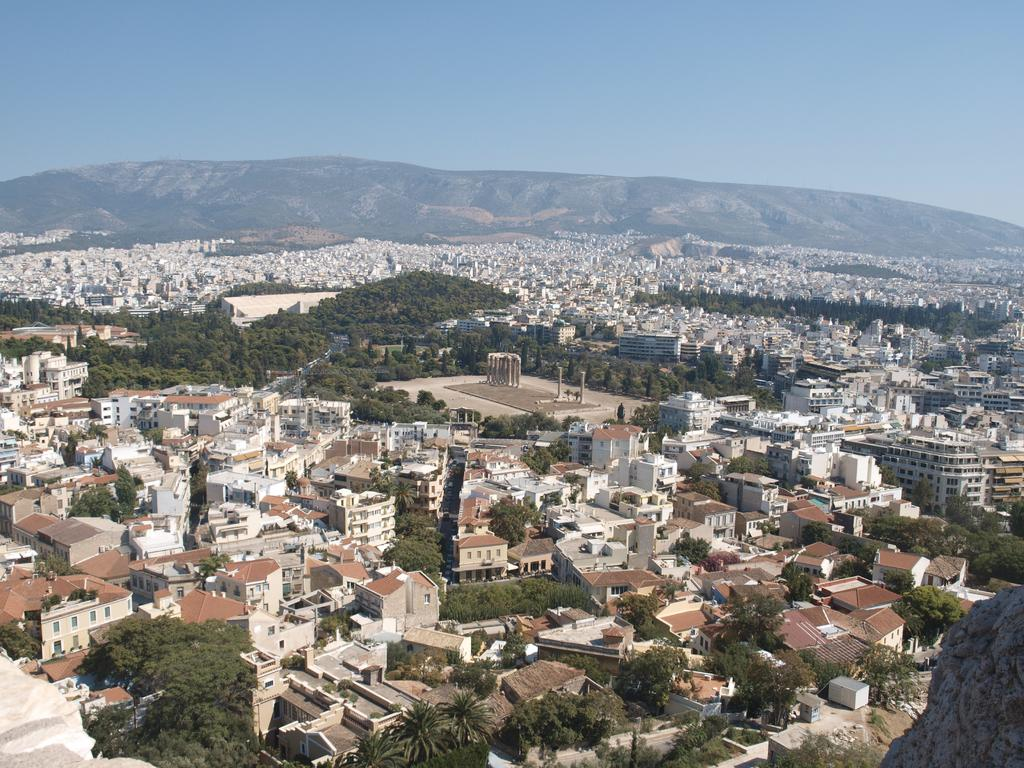What perspective is used in the image? The image provides a top view of an area. What structures can be seen in the image? There are multiple buildings in the image. What type of vegetation is present in the image? There are trees in the image. What type of suit is the bear wearing in the image? There is no bear present in the image, and therefore no suit can be observed. 